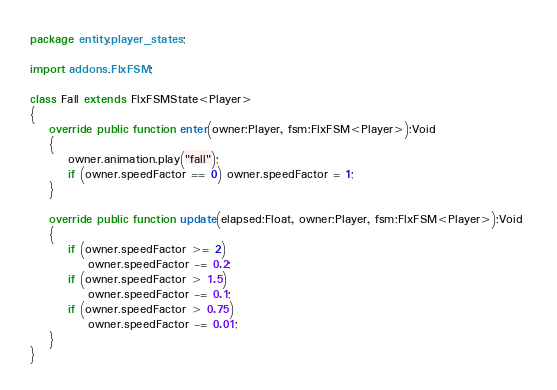Convert code to text. <code><loc_0><loc_0><loc_500><loc_500><_Haxe_>package entity.player_states;

import addons.FlxFSM;

class Fall extends FlxFSMState<Player>
{
    override public function enter(owner:Player, fsm:FlxFSM<Player>):Void 
    {
        owner.animation.play("fall");
        if (owner.speedFactor == 0) owner.speedFactor = 1;
    }
    
    override public function update(elapsed:Float, owner:Player, fsm:FlxFSM<Player>):Void 
    {
        if (owner.speedFactor >= 2)
            owner.speedFactor -= 0.2;
        if (owner.speedFactor > 1.5)
            owner.speedFactor -= 0.1;
        if (owner.speedFactor > 0.75)
            owner.speedFactor -= 0.01;
    }
}</code> 